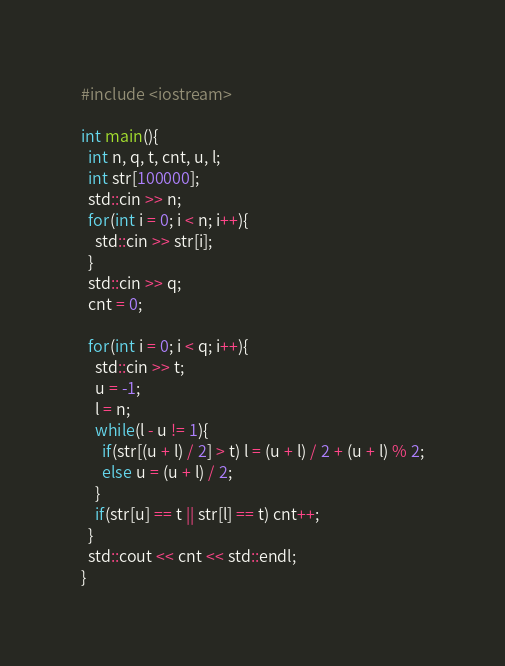<code> <loc_0><loc_0><loc_500><loc_500><_C++_>#include <iostream>
 
int main(){
  int n, q, t, cnt, u, l;
  int str[100000];
  std::cin >> n;
  for(int i = 0; i < n; i++){
    std::cin >> str[i];
  }
  std::cin >> q;
  cnt = 0;
 
  for(int i = 0; i < q; i++){
    std::cin >> t;
    u = -1;
    l = n;
    while(l - u != 1){
      if(str[(u + l) / 2] > t) l = (u + l) / 2 + (u + l) % 2;
      else u = (u + l) / 2;
    }
    if(str[u] == t || str[l] == t) cnt++;
  }
  std::cout << cnt << std::endl;
}
</code> 